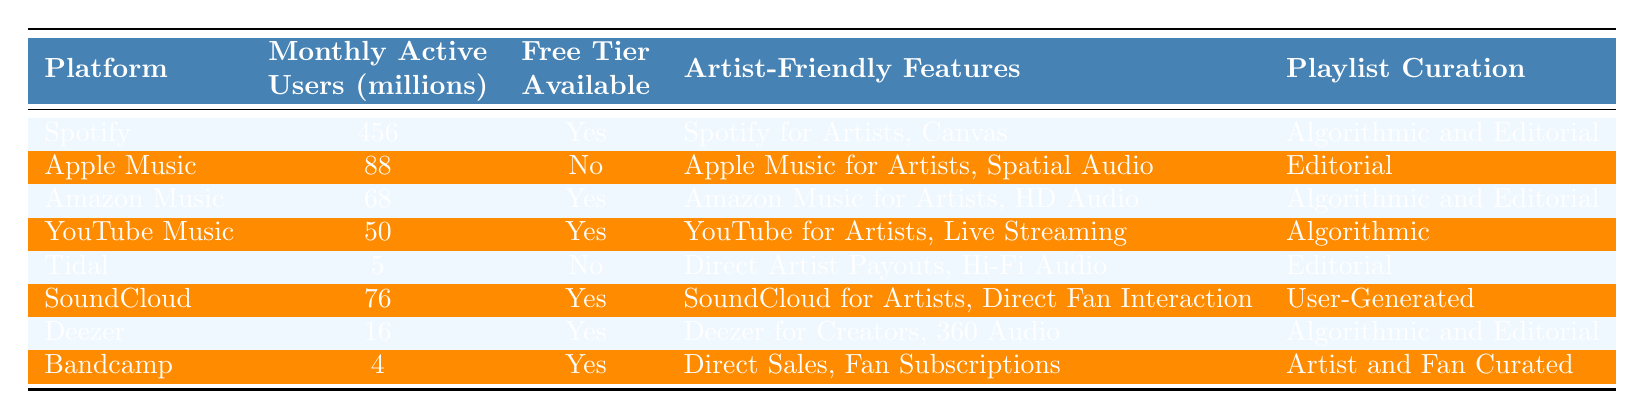What is the monthly active user count for Spotify? The table lists the monthly active users for Spotify as 456 million.
Answer: 456 million Which platform has the least monthly active users? Looking at the "Monthly Active Users (millions)" column, Tidal has the least at 5 million.
Answer: Tidal Is there a free tier available on Apple Music? According to the "Free Tier Available" column, Apple Music does not have a free tier available, as indicated by "No."
Answer: No How many platforms have a free tier available? From the table, the platforms with a free tier are Spotify, Amazon Music, YouTube Music, SoundCloud, Deezer, and Bandcamp. Counting them gives a total of 6 platforms.
Answer: 6 What is the average number of monthly active users for platforms that offer a free tier? The monthly active users for platforms with a free tier are: Spotify (456), Amazon Music (68), YouTube Music (50), SoundCloud (76), Deezer (16), and Bandcamp (4). Adding them together gives 670, and dividing by the number of platforms (6) provides an average of 111.67 million.
Answer: 111.67 million Does Tidal have any artist-friendly features? The table indicates that Tidal offers "Direct Artist Payouts, Hi-Fi Audio" as artist-friendly features, which confirms that it does have them.
Answer: Yes Which platform has both algorithmic and editorial playlist curation? The platforms with both types of playlist curation are Spotify and Amazon Music, according to the "Playlist Curation" column of the table.
Answer: Spotify, Amazon Music How many platforms have user-generated playlist curation features? The table shows that only SoundCloud has user-generated playlist curation as stated in the "Playlist Curation" column.
Answer: 1 What is the total number of monthly active users for platforms without a free tier? The platforms without a free tier are Apple Music (88) and Tidal (5). Adding these gives a total of 93 million monthly active users.
Answer: 93 million Overall, which platform has the most artist-friendly features? Examining the "Artist-Friendly Features" column, Spotify has "Spotify for Artists, Canvas," which is more comprehensive than the offerings of other platforms.
Answer: Spotify 